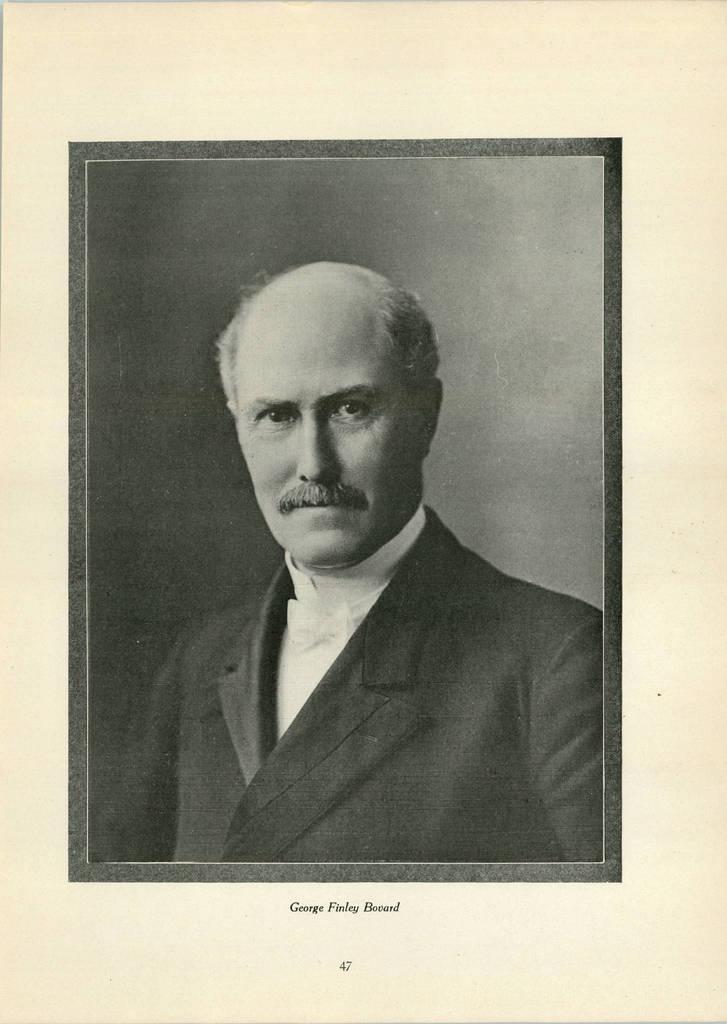Please provide a concise description of this image. This is a black and white image. In this picture, we see a man is wearing a white shirt and a black blazer. He is posing for the photo. In the background, it is black in color. This picture might be a photo frame or a poster. In the background, it is white in color. At the bottom, we see some text written on it. 